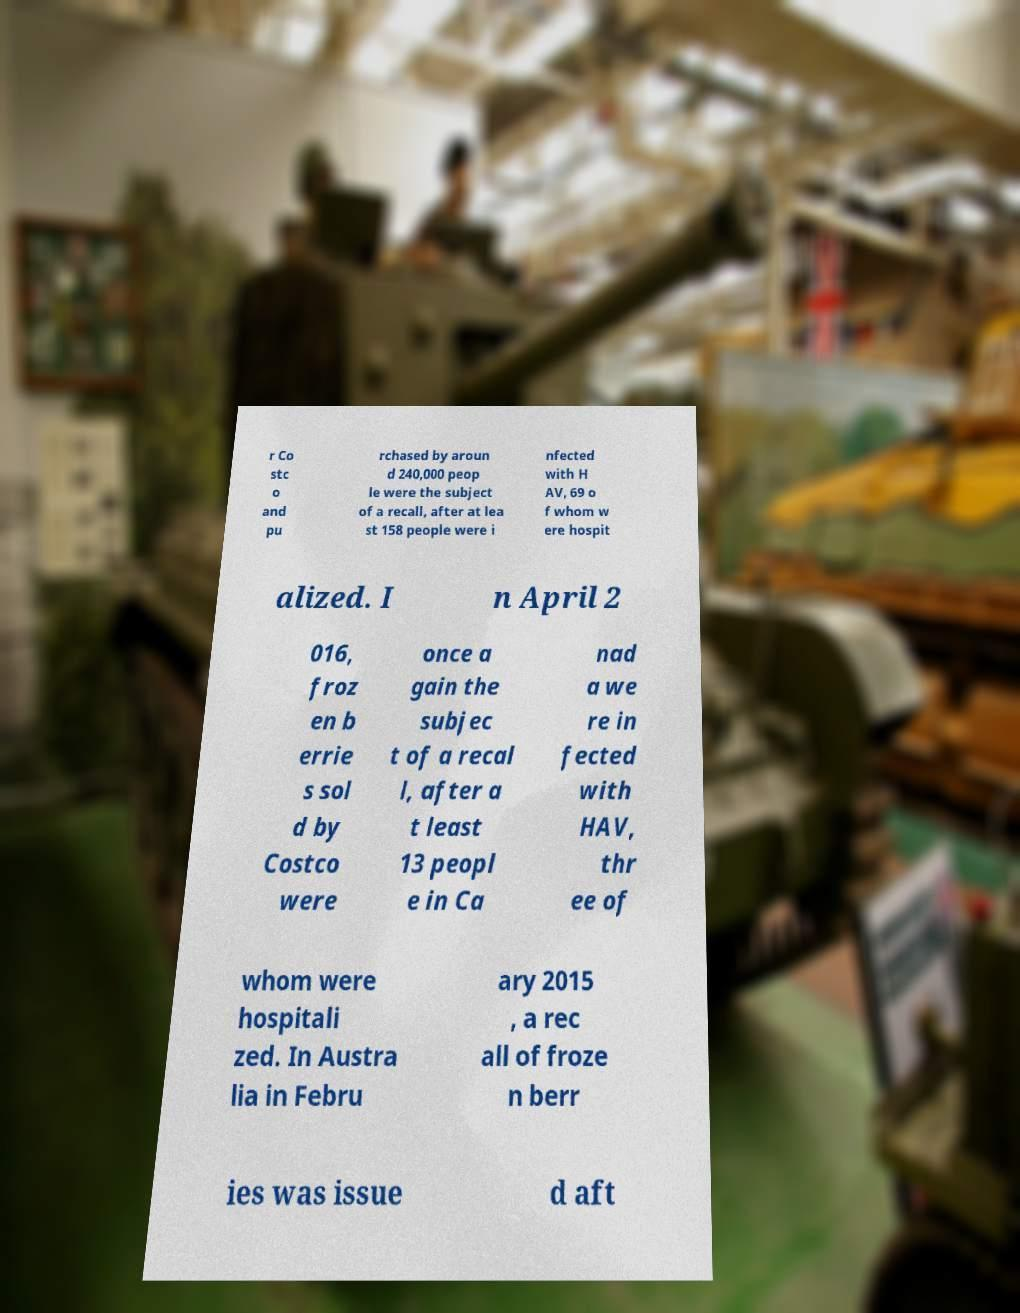What messages or text are displayed in this image? I need them in a readable, typed format. r Co stc o and pu rchased by aroun d 240,000 peop le were the subject of a recall, after at lea st 158 people were i nfected with H AV, 69 o f whom w ere hospit alized. I n April 2 016, froz en b errie s sol d by Costco were once a gain the subjec t of a recal l, after a t least 13 peopl e in Ca nad a we re in fected with HAV, thr ee of whom were hospitali zed. In Austra lia in Febru ary 2015 , a rec all of froze n berr ies was issue d aft 